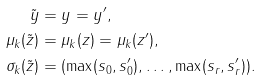Convert formula to latex. <formula><loc_0><loc_0><loc_500><loc_500>\tilde { y } & = y = y ^ { \prime } , \\ \mu _ { k } ( \tilde { z } ) & = \mu _ { k } ( z ) = \mu _ { k } ( z ^ { \prime } ) , \\ \sigma _ { k } ( \tilde { z } ) & = ( \max ( s _ { 0 } , s ^ { \prime } _ { 0 } ) , \dots , \max ( s _ { r } , s ^ { \prime } _ { r } ) ) .</formula> 